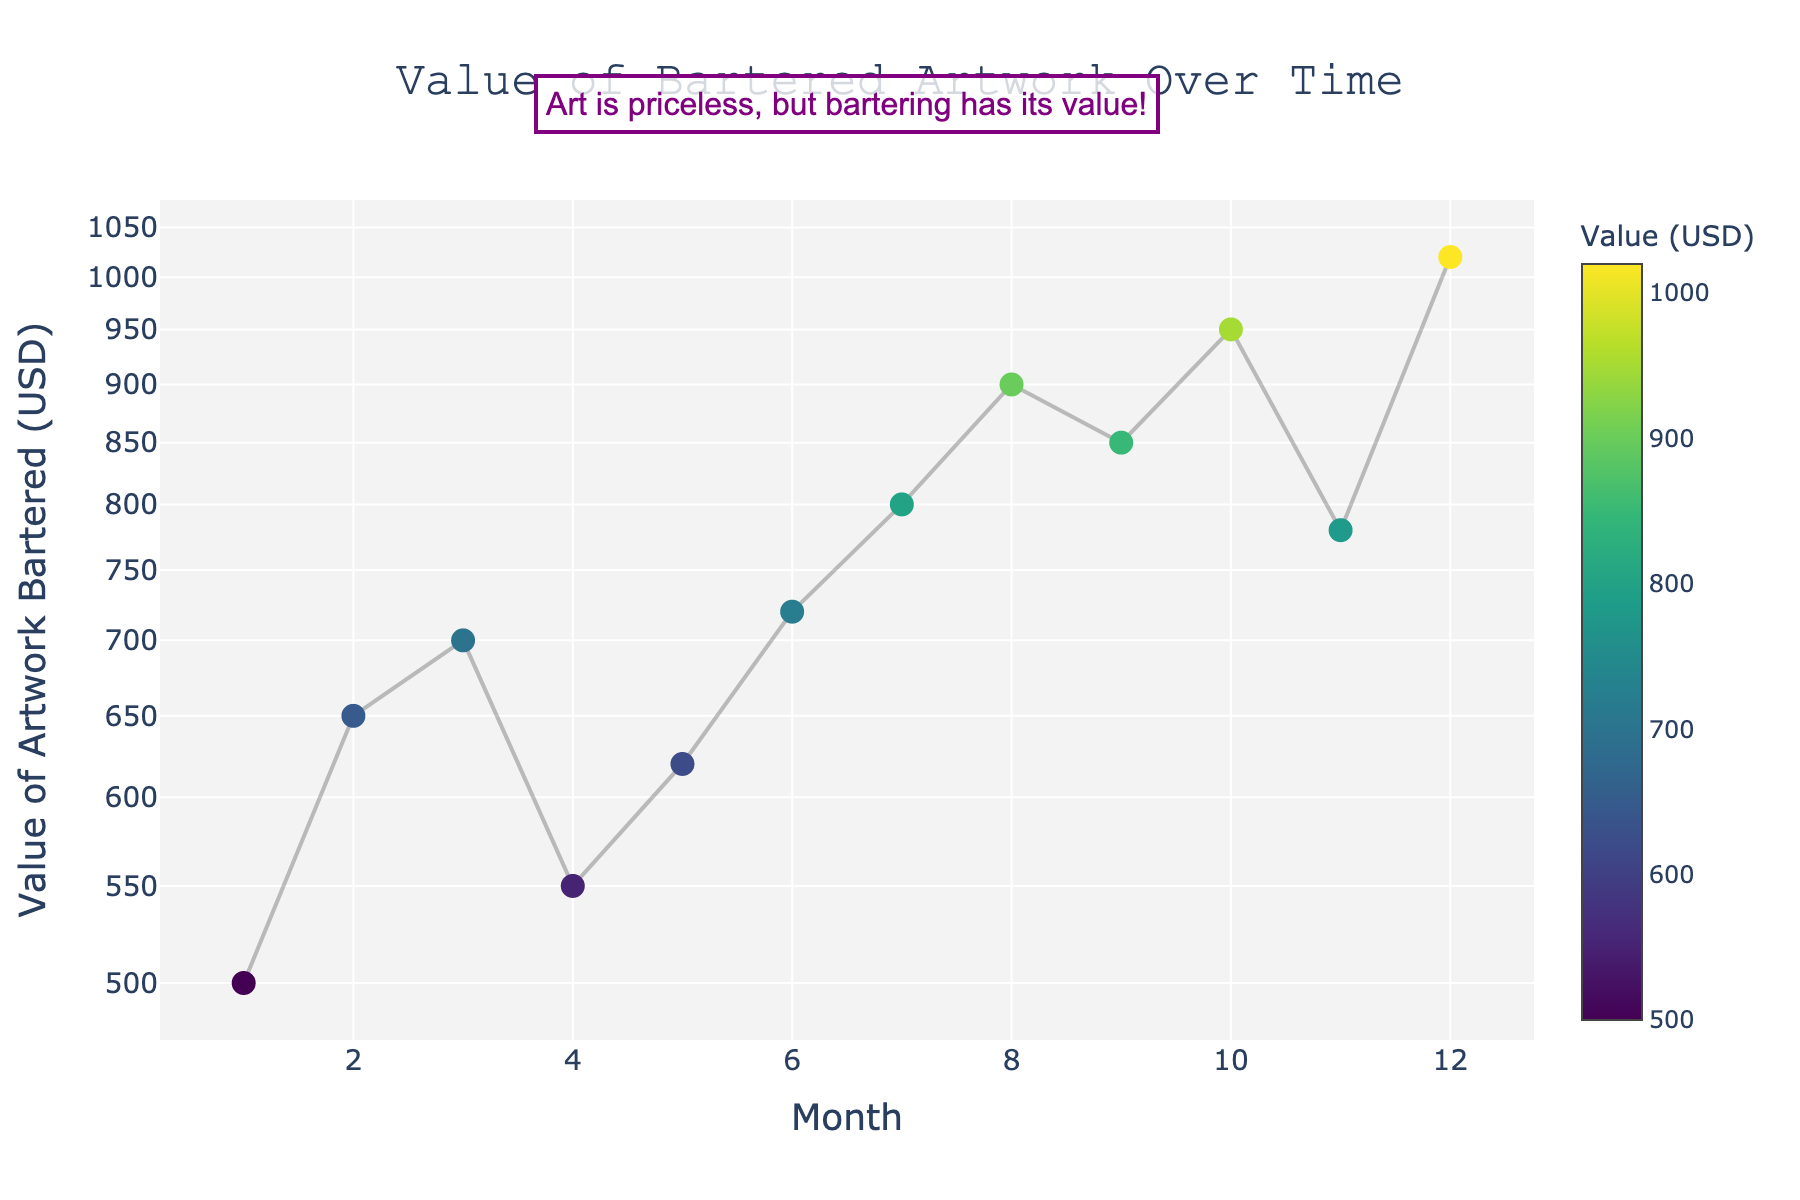How many months are represented in the scatter plot? Count the number of data points along the x-axis which represents the months.
Answer: 12 What is the title of the scatter plot? The title is displayed at the top of the scatter plot.
Answer: Value of Bartered Artwork Over Time In which month was the highest value of artwork bartered? Look for the month corresponding to the highest y-value.
Answer: 12 What is the y-axis title? The y-axis title is written vertically alongside the y-axis.
Answer: Value of Artwork Bartered (USD) What color scale is used for the markers, and where is the scale shown? The color of the markers and the color scale legend representation needs to be observed.
Answer: Viridis; shown on the right Is the trend of the value of bartered artwork increasing, decreasing, or constant over time? Observe whether the y-values generally increase, decrease, or remain constant as the x-values increase.
Answer: Increasing What is the value of artwork bartered in the 6th month? Locate the data point corresponding to the 6th month and read the y-value.
Answer: 720 By approximately how much did the value of bartered artwork increase from the 4th to the 5th month? Subtract the value of the 4th month from the value of the 5th month.
Answer: 70 Which months had the lowest and highest values of bartered artwork, respectively? Identify the month for the minimal y-value and the maximal y-value.
Answer: Lowest: 1; Highest: 12 How does the annotation contribute to the overall theme of the scatter plot? Observe the annotation and relate it to the theme of artwork and bartering.
Answer: It adds an artistic and contextual touch by highlighting the value flexibility in bartering What kind of scale is used on the y-axis, and why might this be useful? Look at the y-axis labels and spacing; they indicate if a log scale is used.
Answer: Log scale; useful for visualizing a wide range of values effectively 